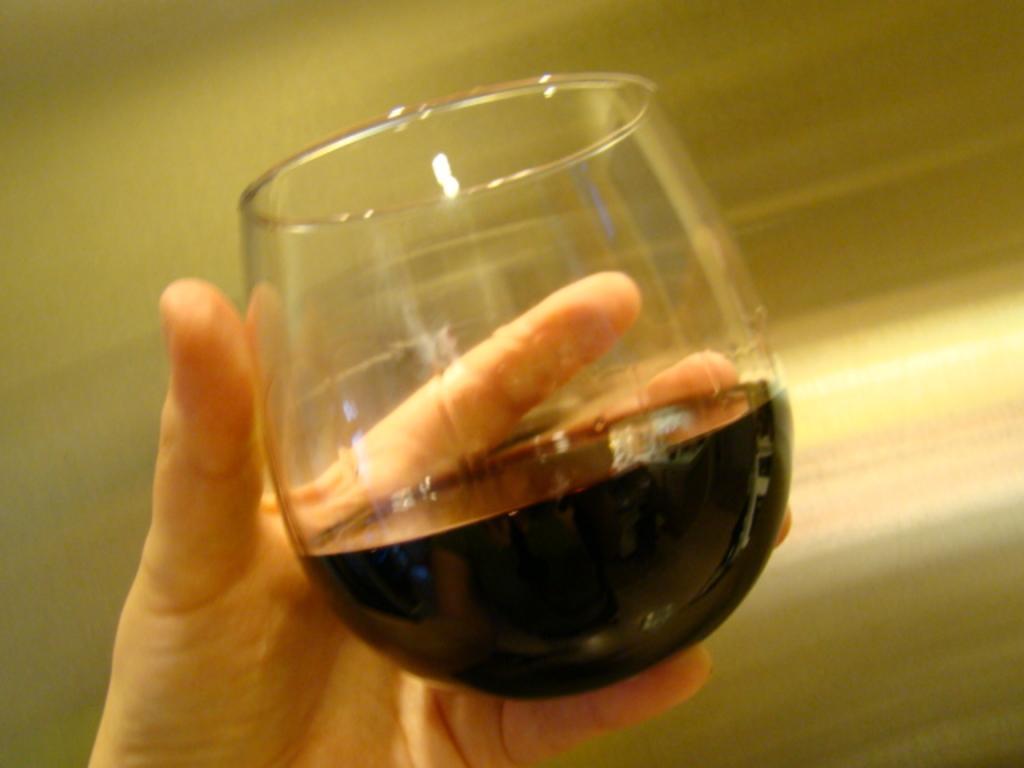Could you give a brief overview of what you see in this image? In this image I can see a human hand holding a wine glass with a black colored liquid in it. I can see the blurry background. 